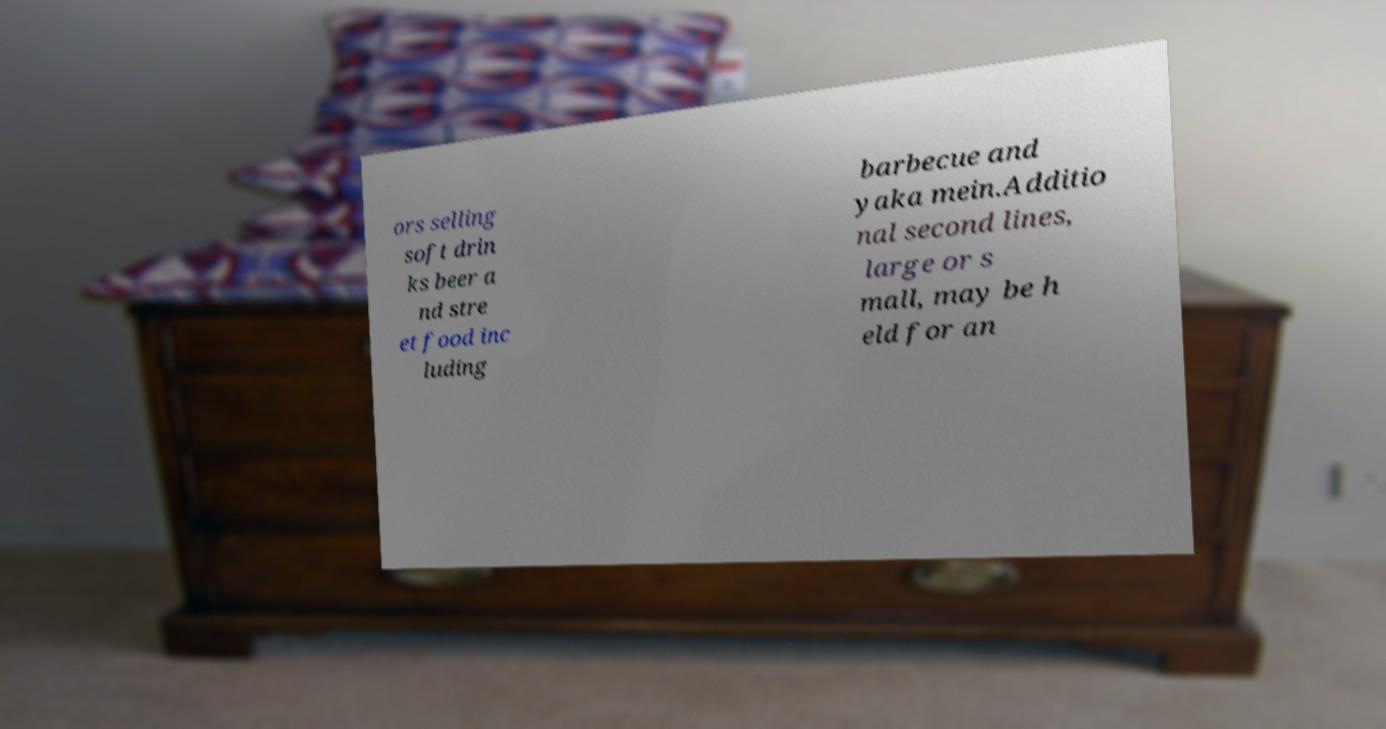Please identify and transcribe the text found in this image. ors selling soft drin ks beer a nd stre et food inc luding barbecue and yaka mein.Additio nal second lines, large or s mall, may be h eld for an 